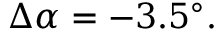<formula> <loc_0><loc_0><loc_500><loc_500>\Delta \alpha = - 3 . 5 ^ { \circ } .</formula> 